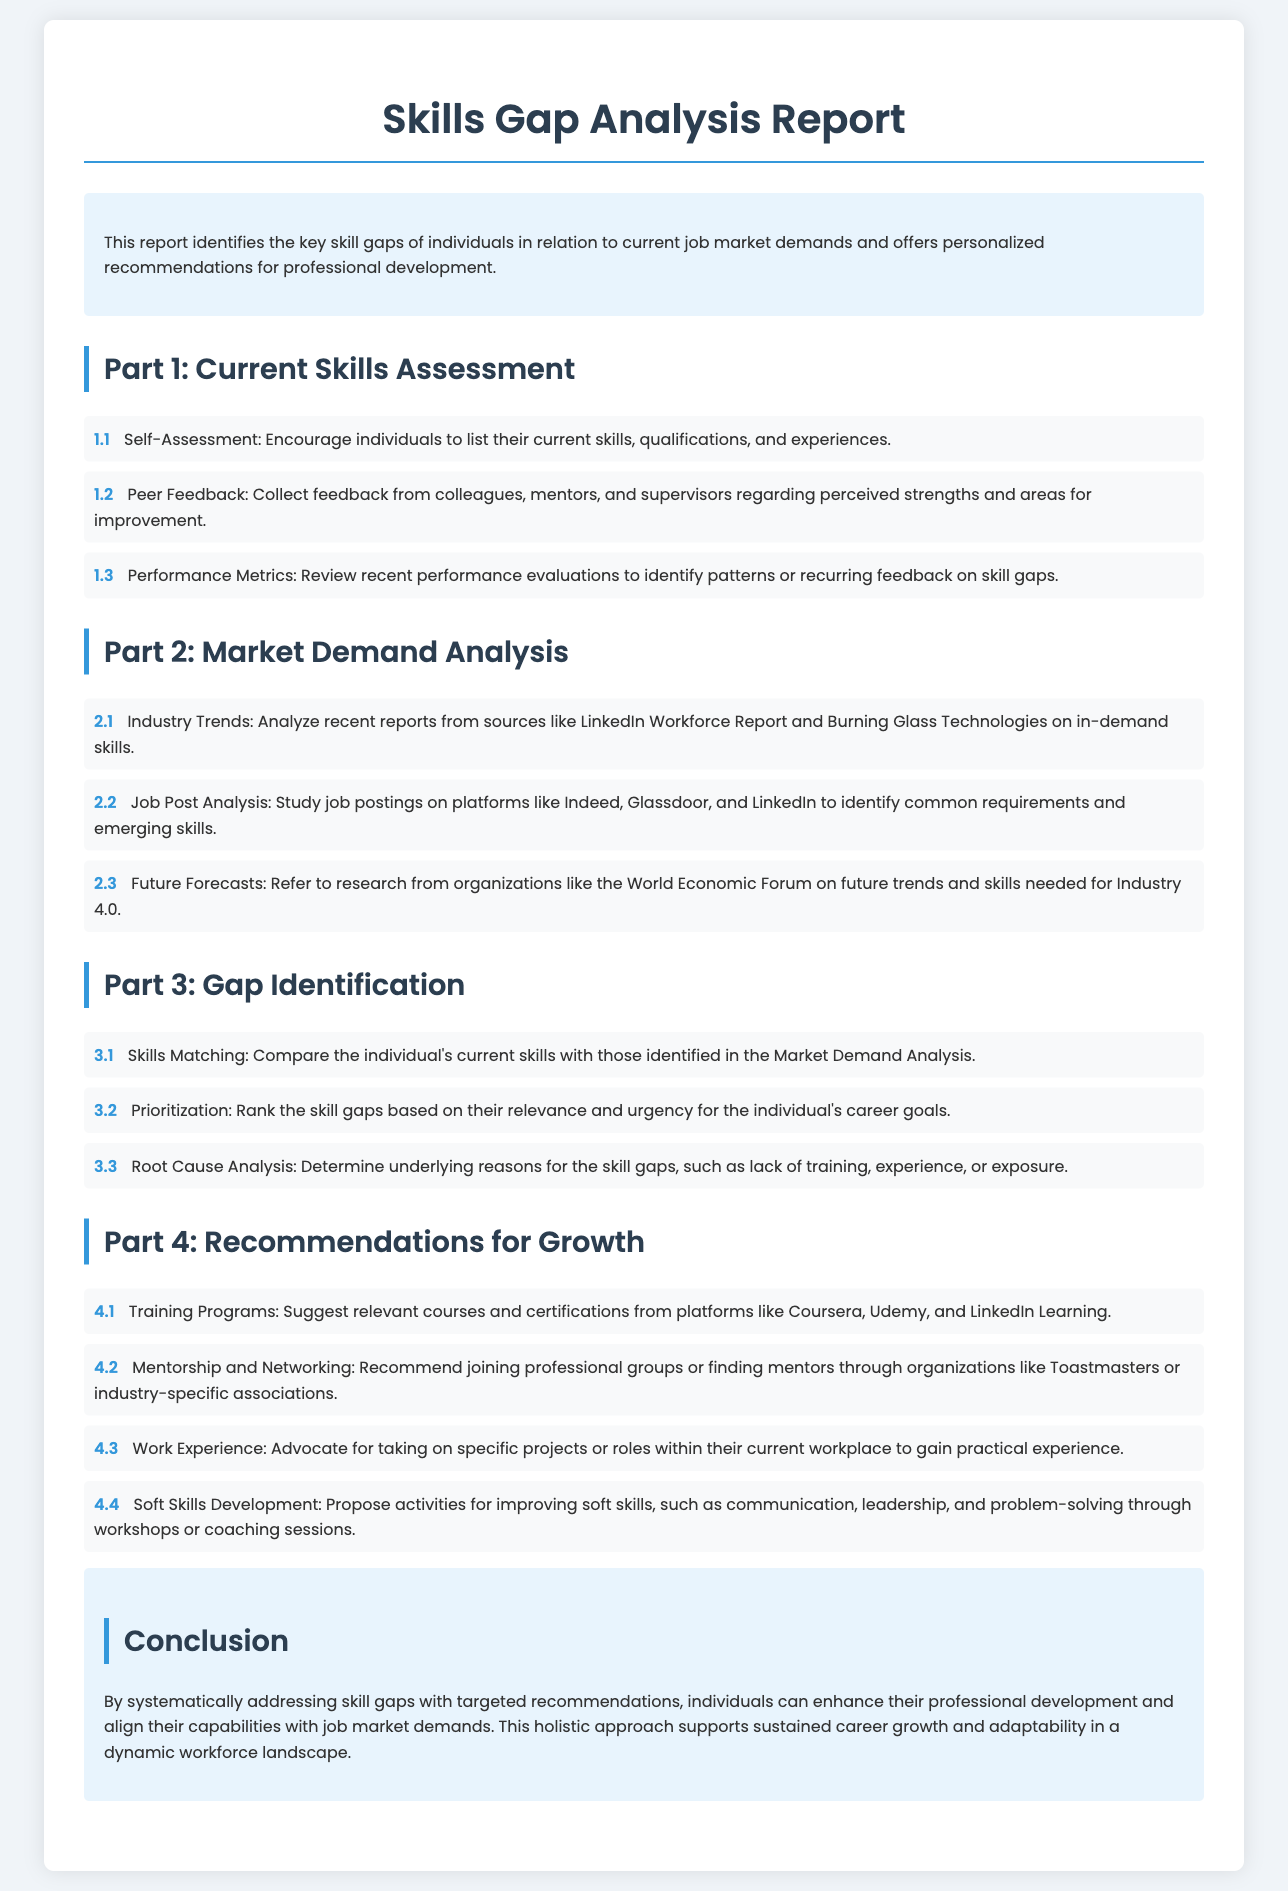What is the title of the document? The title of the document is presented at the top of the document.
Answer: Skills Gap Analysis Report What is the purpose of the report? The purpose is to identify skill gaps and provide recommendations for professional development.
Answer: personalized recommendations for professional development What section discusses peer feedback? Peer feedback is addressed in the Current Skills Assessment section.
Answer: Part 1: Current Skills Assessment What type of analysis does Part 2 focus on? Part 2 focuses on analyzing the job market and its demands.
Answer: Market Demand Analysis How many parts are there in the report? The number of parts in the report is mentioned in the structure of the document.
Answer: 4 Which platforms are recommended for training programs? The report suggests specific platforms for training programs in its recommendations.
Answer: Coursera, Udemy, and LinkedIn Learning What does the report recommend for soft skills development? The document proposes specific activities for improving a category of skills.
Answer: workshops or coaching sessions Which organization's research is referenced for future skills? The report mentions a research organization that forecasts future skills needed.
Answer: World Economic Forum What is encouraged in the self-assessment section? The self-assessment section encourages individuals to reflect on their current skills.
Answer: list their current skills, qualifications, and experiences 